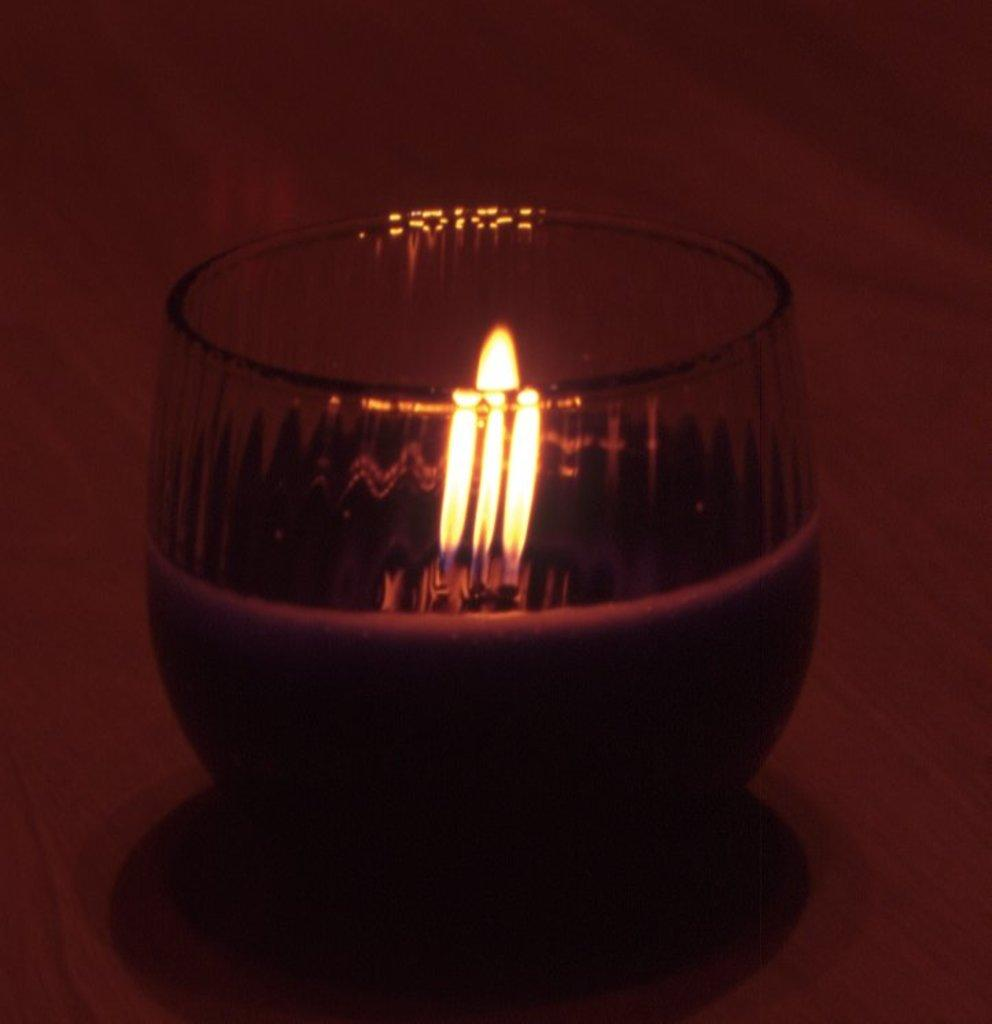What object can be seen in the image that provides light? There is a lamp in the image. How is the lamp contained or displayed in the image? The lamp is placed in a glass. Where is the lamp and glass located in the image? The lamp and glass are on a surface. What type of growth or increase can be observed in the image? There is no growth or increase observable in the image; it features a lamp placed in a glass on a surface. Is there a calendar visible in the image? There is no calendar present in the image. 